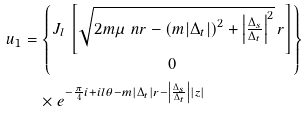Convert formula to latex. <formula><loc_0><loc_0><loc_500><loc_500>u _ { 1 } & = \begin{Bmatrix} J _ { l } \, \left [ \sqrt { 2 m \mu _ { \ } n r - \left ( m | \Delta _ { t } | \right ) ^ { 2 } + \left | \frac { \Delta _ { s } } { \Delta _ { t } } \right | ^ { 2 } } \, r \right ] \\ 0 \end{Bmatrix} \\ & \quad \times e ^ { - \frac { \pi } { 4 } i + i l \theta - m | \Delta _ { t } | r - \left | \frac { \Delta _ { s } } { \Delta _ { t } } \right | | z | }</formula> 